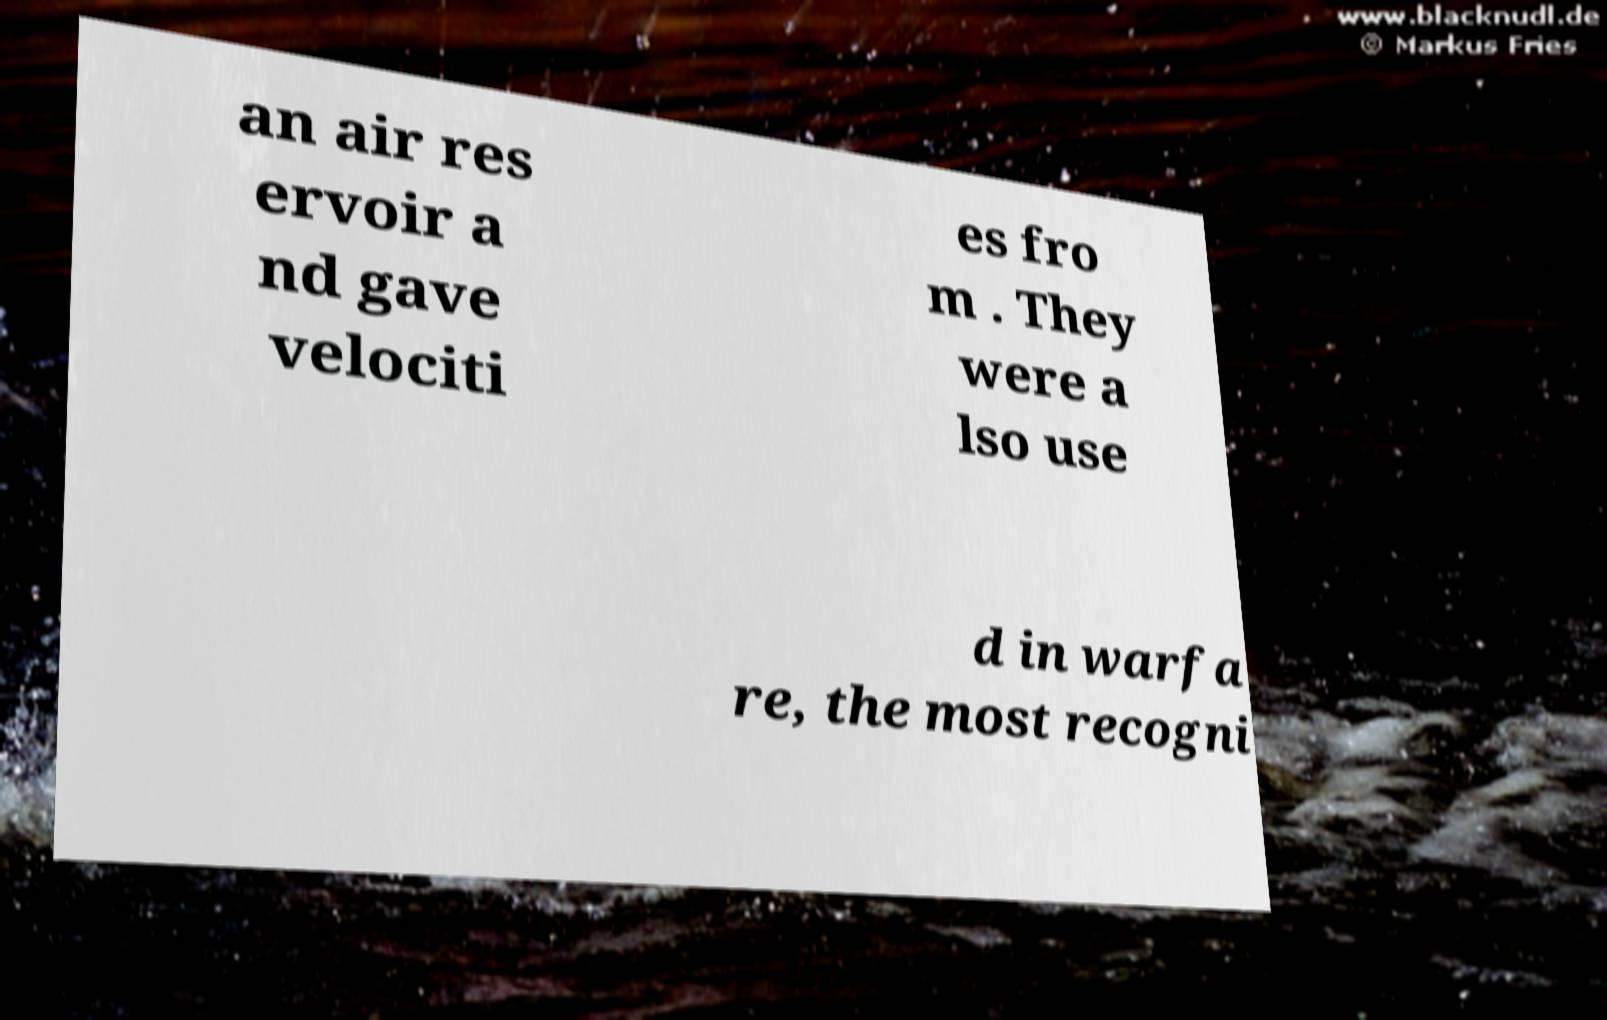For documentation purposes, I need the text within this image transcribed. Could you provide that? an air res ervoir a nd gave velociti es fro m . They were a lso use d in warfa re, the most recogni 